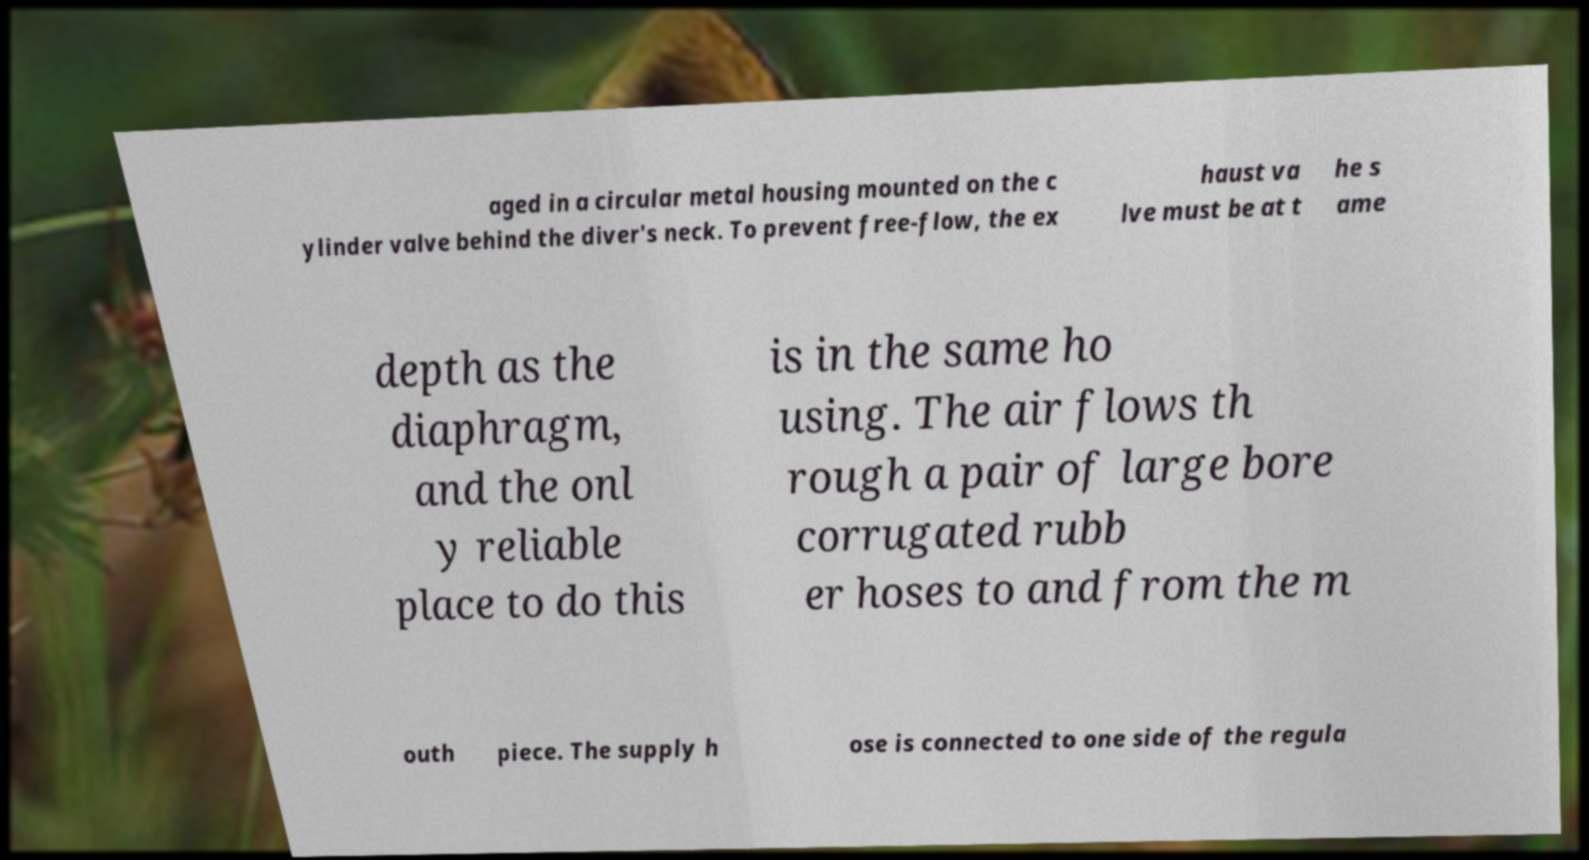For documentation purposes, I need the text within this image transcribed. Could you provide that? aged in a circular metal housing mounted on the c ylinder valve behind the diver's neck. To prevent free-flow, the ex haust va lve must be at t he s ame depth as the diaphragm, and the onl y reliable place to do this is in the same ho using. The air flows th rough a pair of large bore corrugated rubb er hoses to and from the m outh piece. The supply h ose is connected to one side of the regula 